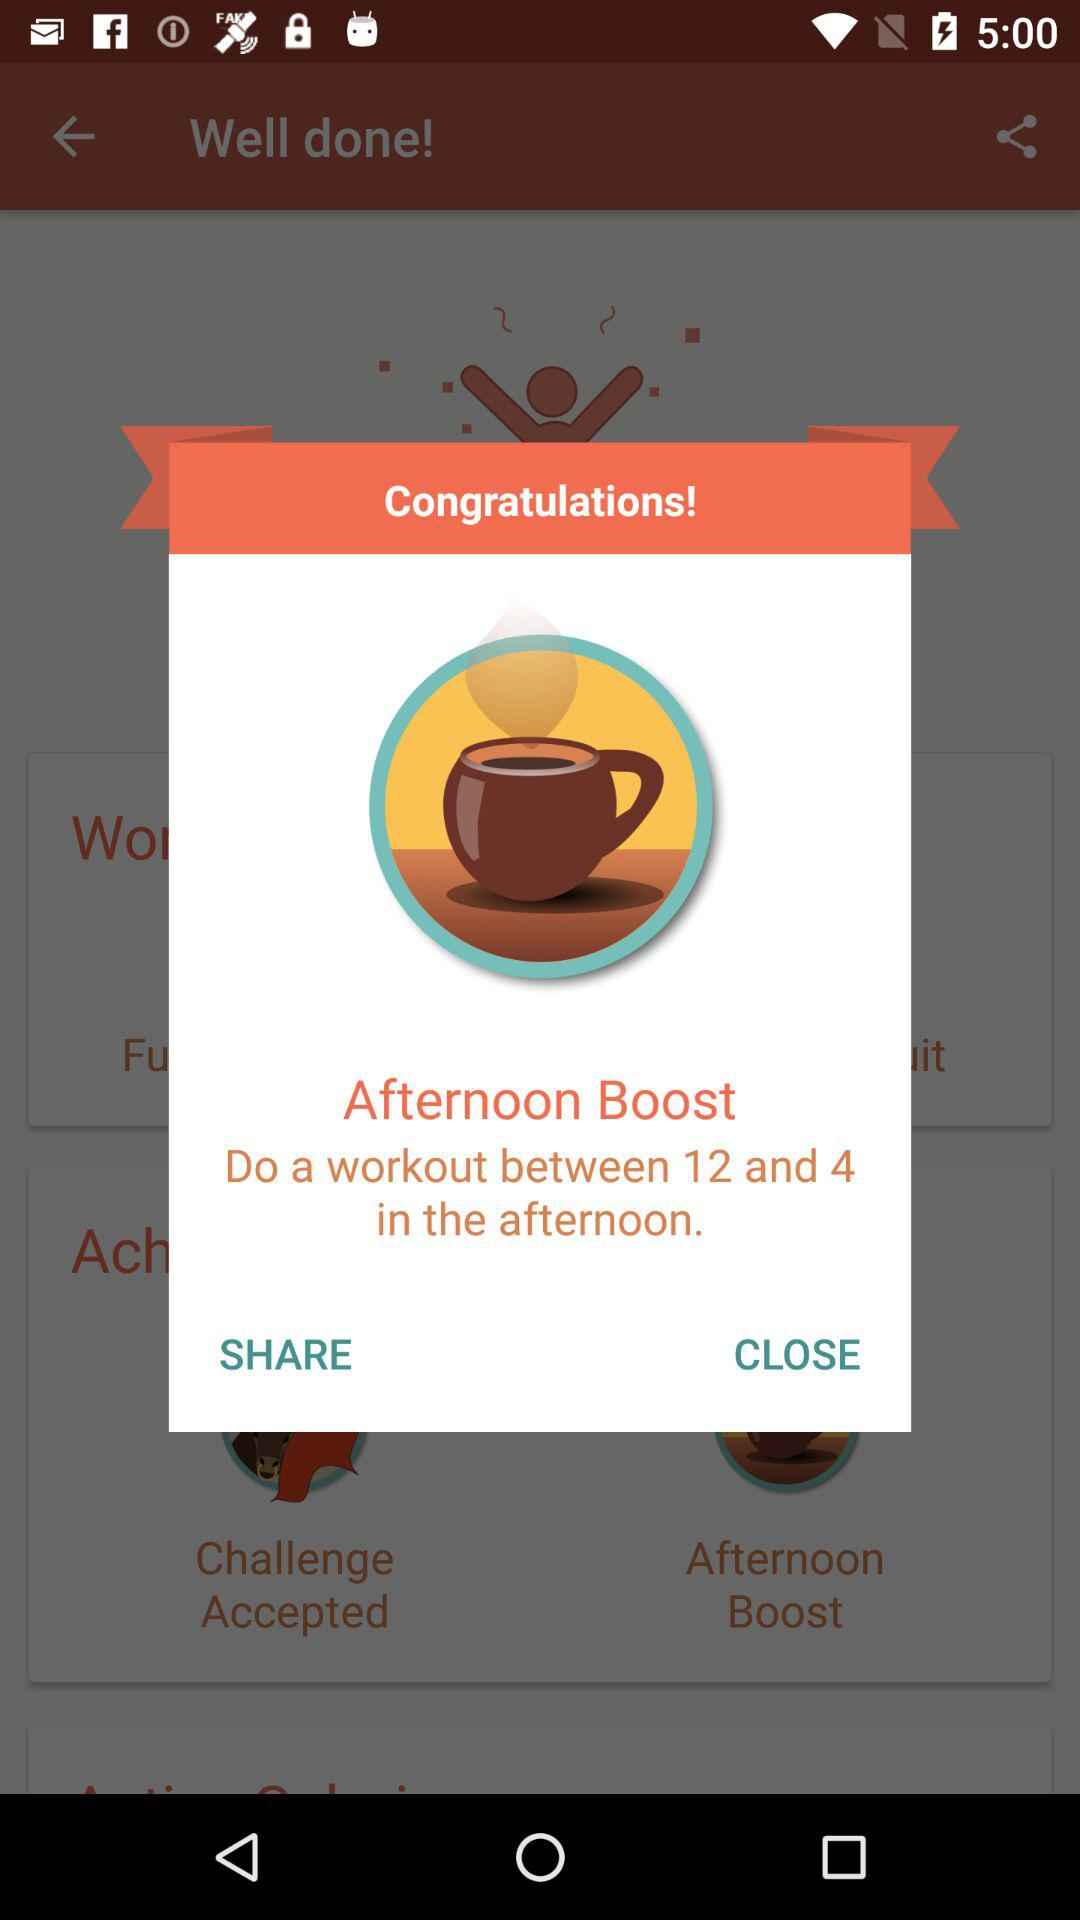What can I do for an afternoon boost? For an afternoon boost, do a workout between 12 and 4 in the afternoon. 